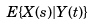<formula> <loc_0><loc_0><loc_500><loc_500>E \{ X ( s ) | Y ( t ) \}</formula> 